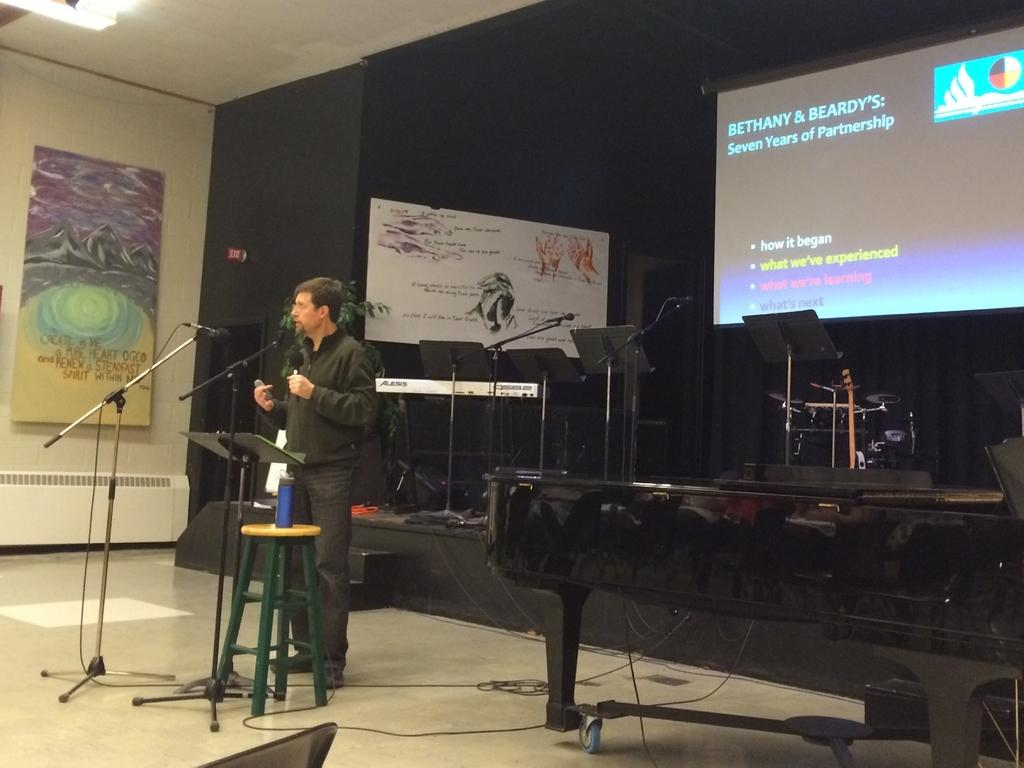What is the man in the image doing? The man is standing next to a mic. Are there any other mics visible in the image? Yes, there are additional mics in the background. What can be seen on the screen in the background? The facts do not specify what is on the screen, so we cannot answer that question definitively. What type of insect can be seen crawling on the bottle in the image? There is no bottle present in the image, so there is no insect to be seen crawling on it. 